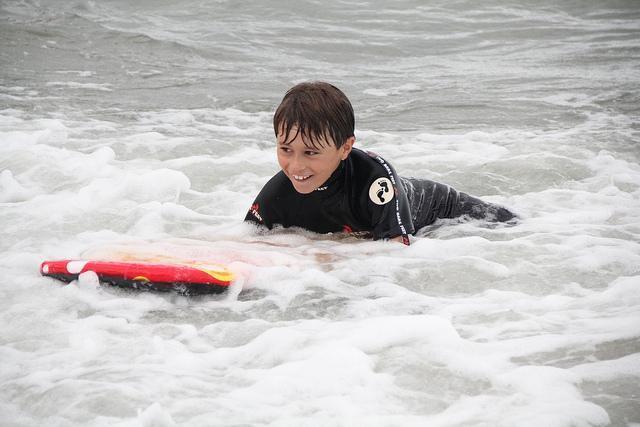How many cars are in this scene?
Give a very brief answer. 0. 